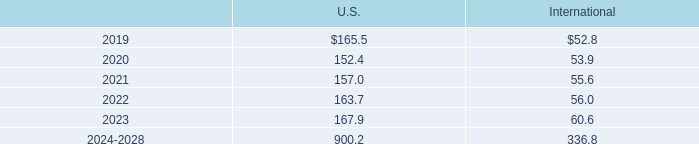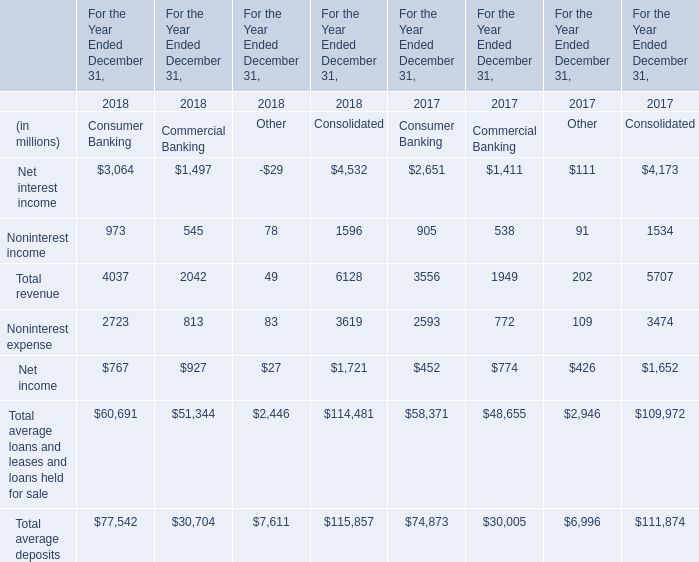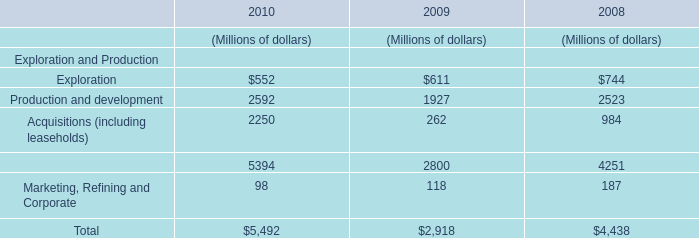In the year with largest amount of total average deposits of consolidated, what's the increasing rate of total revenue? 
Computations: ((6128 - 5707) / 5707)
Answer: 0.07377. 